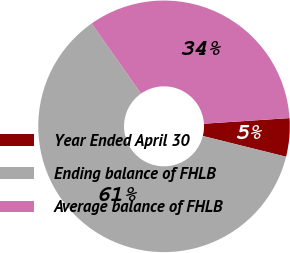<chart> <loc_0><loc_0><loc_500><loc_500><pie_chart><fcel>Year Ended April 30<fcel>Ending balance of FHLB<fcel>Average balance of FHLB<nl><fcel>4.93%<fcel>61.35%<fcel>33.72%<nl></chart> 